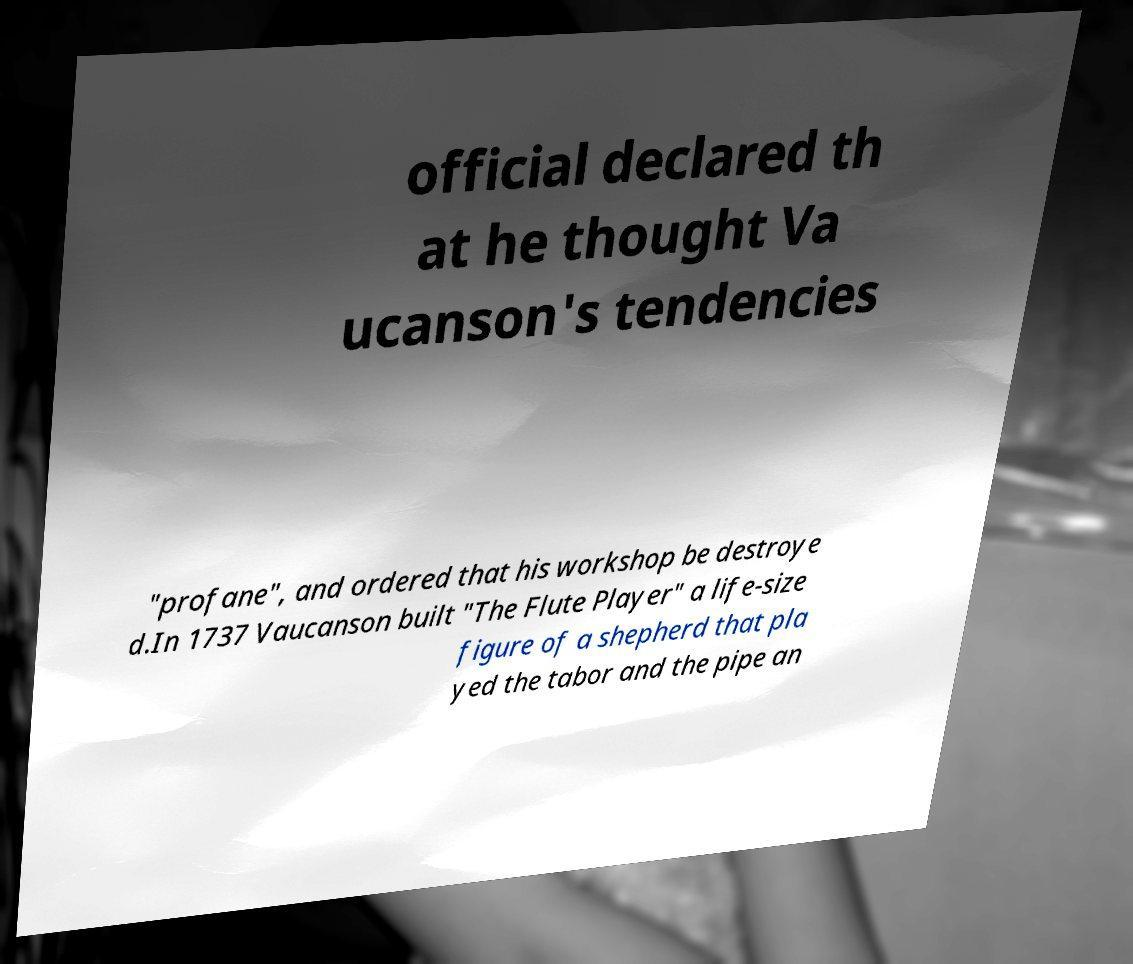Could you assist in decoding the text presented in this image and type it out clearly? official declared th at he thought Va ucanson's tendencies "profane", and ordered that his workshop be destroye d.In 1737 Vaucanson built "The Flute Player" a life-size figure of a shepherd that pla yed the tabor and the pipe an 